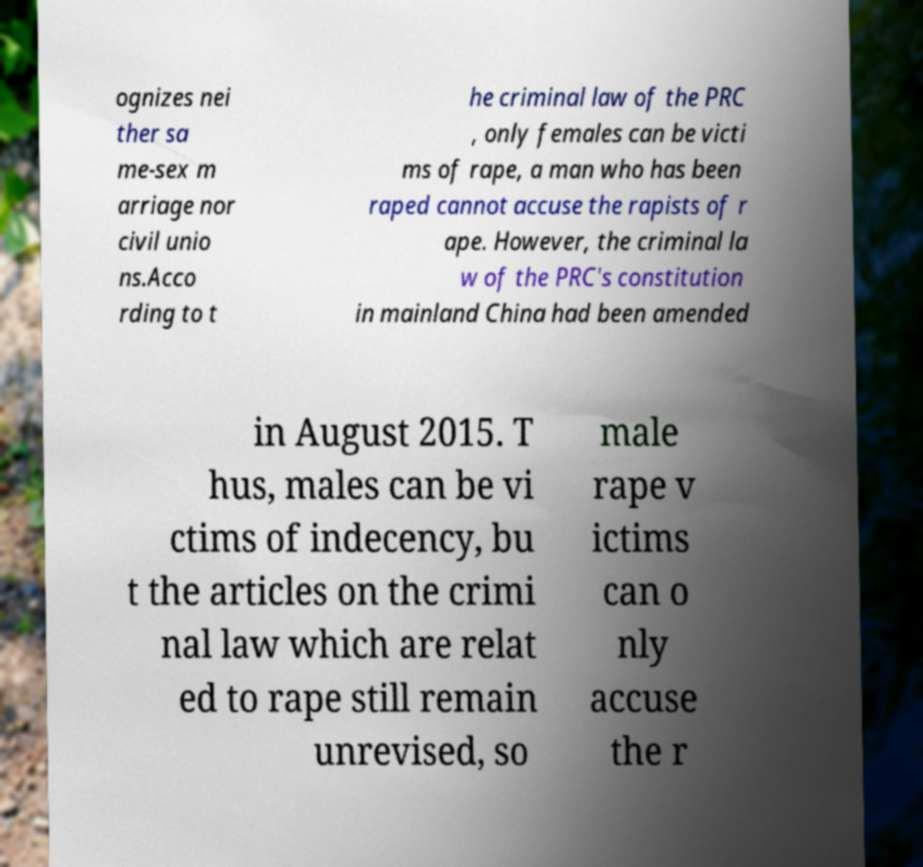Please read and relay the text visible in this image. What does it say? ognizes nei ther sa me-sex m arriage nor civil unio ns.Acco rding to t he criminal law of the PRC , only females can be victi ms of rape, a man who has been raped cannot accuse the rapists of r ape. However, the criminal la w of the PRC's constitution in mainland China had been amended in August 2015. T hus, males can be vi ctims of indecency, bu t the articles on the crimi nal law which are relat ed to rape still remain unrevised, so male rape v ictims can o nly accuse the r 